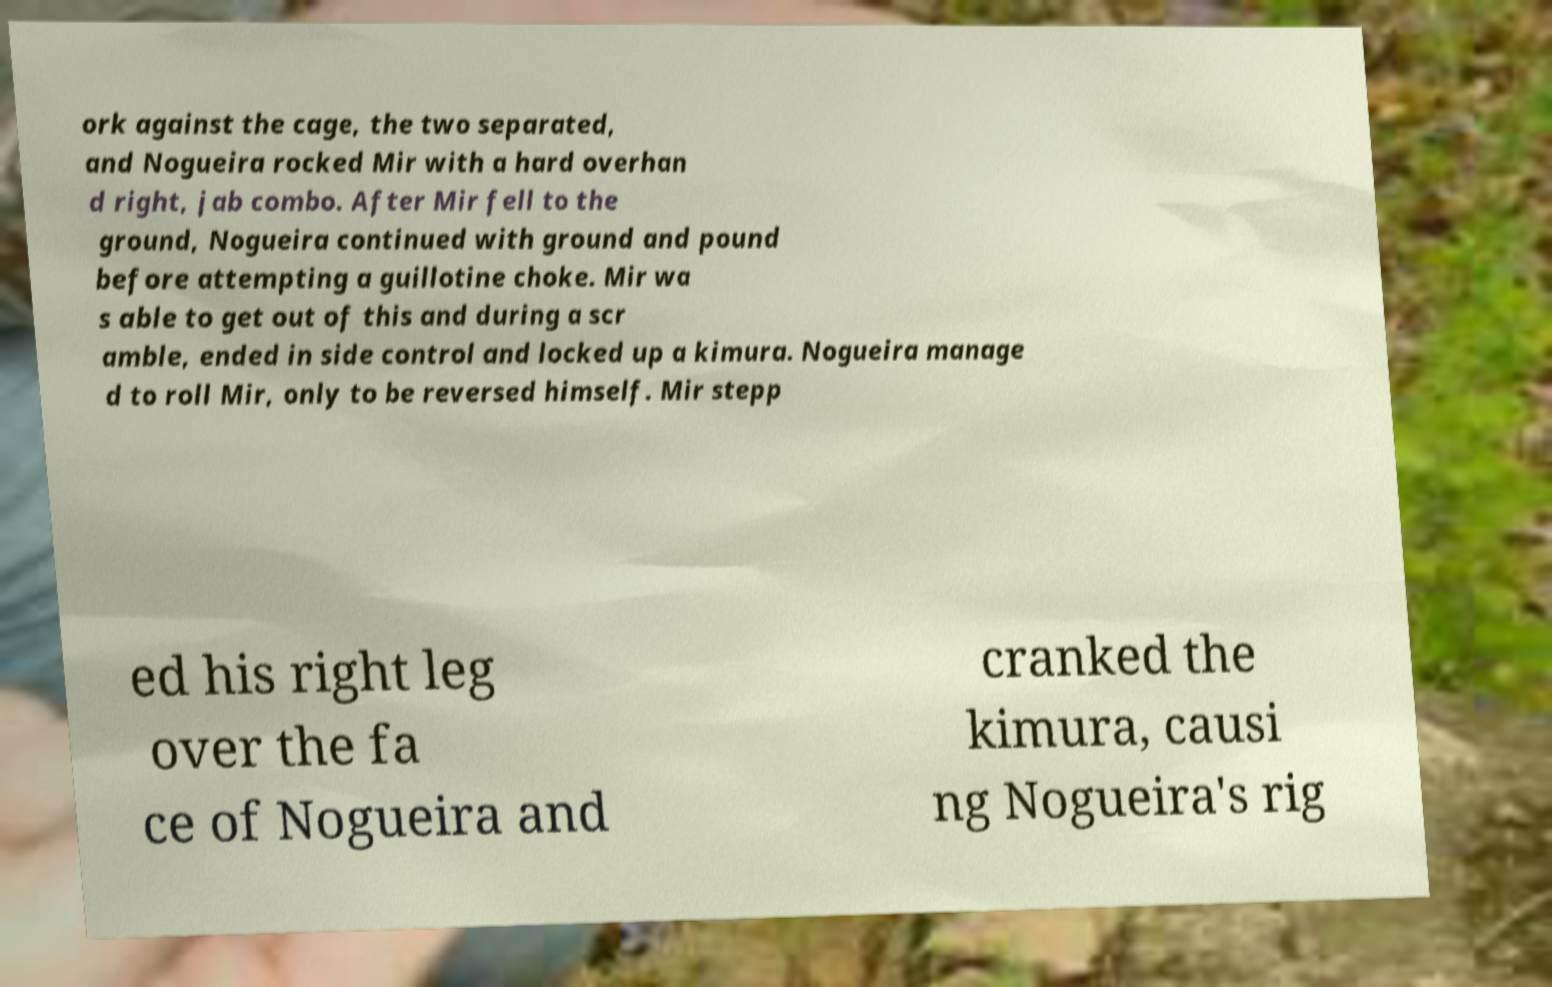Please identify and transcribe the text found in this image. ork against the cage, the two separated, and Nogueira rocked Mir with a hard overhan d right, jab combo. After Mir fell to the ground, Nogueira continued with ground and pound before attempting a guillotine choke. Mir wa s able to get out of this and during a scr amble, ended in side control and locked up a kimura. Nogueira manage d to roll Mir, only to be reversed himself. Mir stepp ed his right leg over the fa ce of Nogueira and cranked the kimura, causi ng Nogueira's rig 